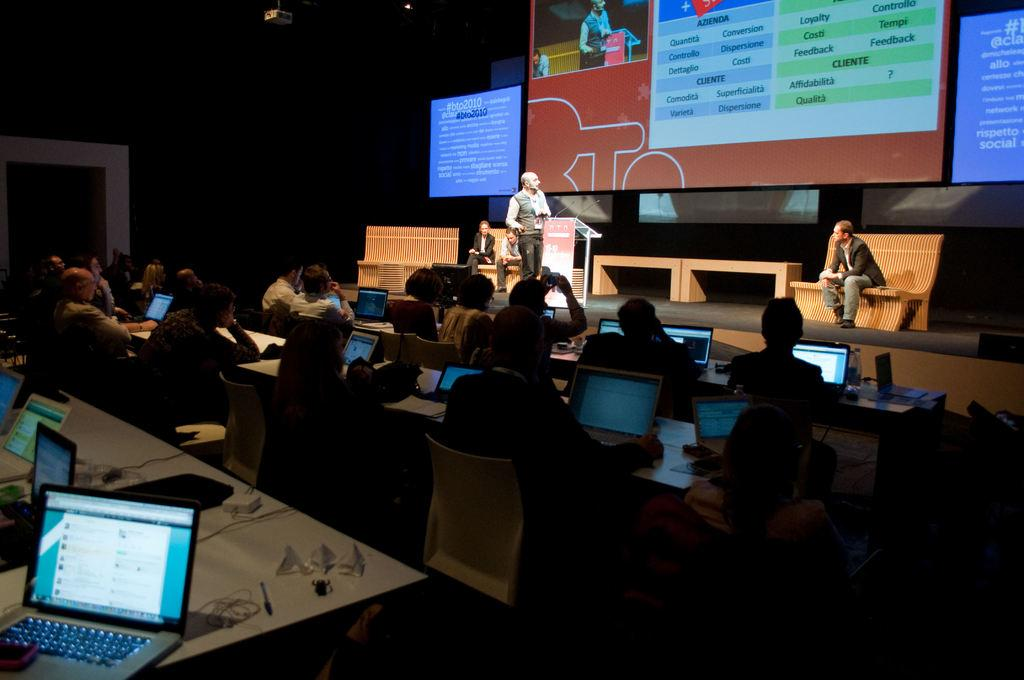<image>
Describe the image concisely. a projection screen with the word azienda on it at the top 